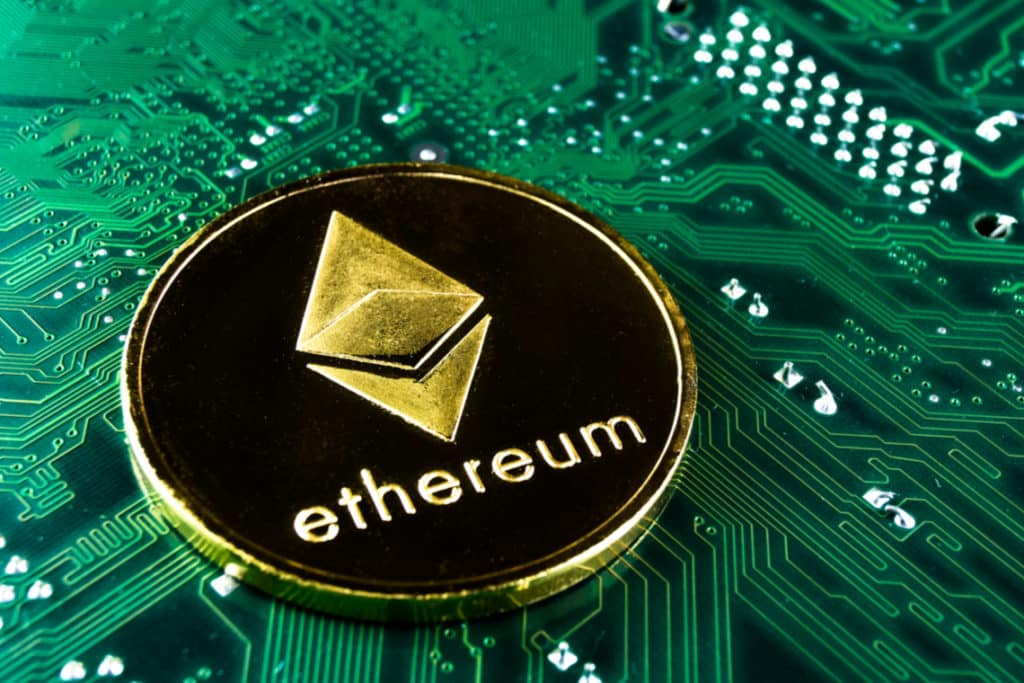Considering the symbolic relationship between the Ethereum coin and the circuit board, what could this image suggest about the interaction between cryptocurrency and technology? The image you’re looking at effectively symbolizes the deep interconnectivity between Ethereum, a leading cryptocurrency, and the underlying technological infrastructure that supports it. Ethereum is not just a digital currency; it is built upon blockchain technology, which requires sophisticated hardware to function seamlessly. The circuit board seen in the image signifies the intricate and advanced systems necessary to support blockchain networks. Without such technology, the cryptocurrency ecosystem, including Ethereum, would not be able to operate. The image vividly illustrates the dependency of digital currencies on the continual advancements in technology, underlining that robust and reliable hardware is fundamental to the success and function of cryptocurrencies. 